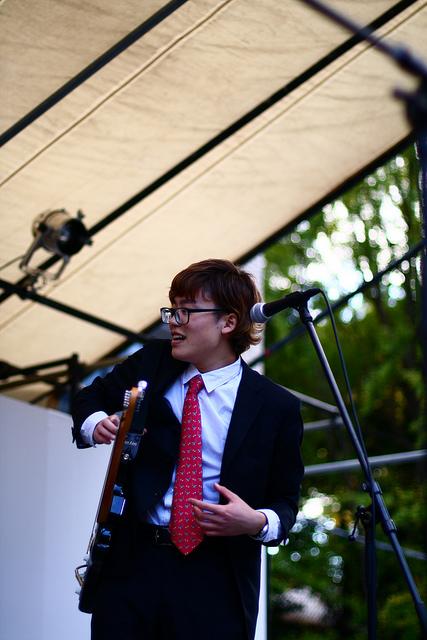What color is his tie?
Short answer required. Red. Is this person playing an instrument?
Keep it brief. Yes. Is that a natural hair color?
Be succinct. Yes. 